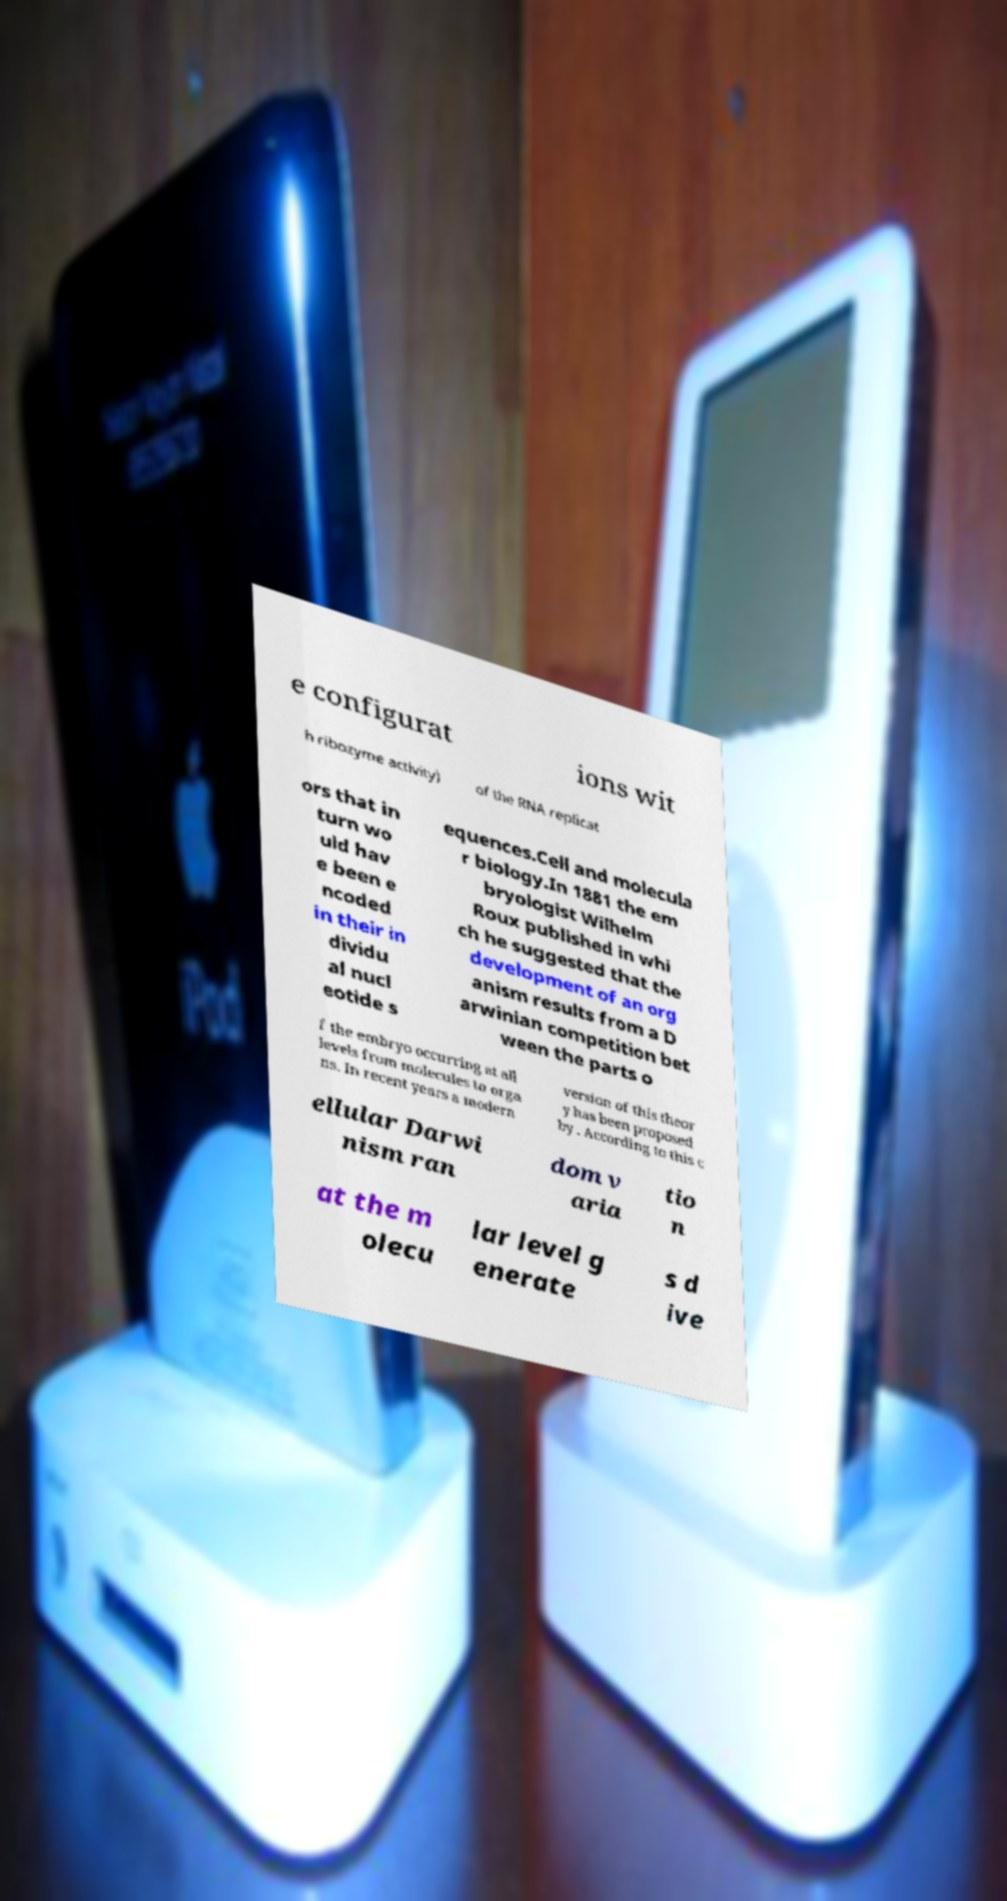There's text embedded in this image that I need extracted. Can you transcribe it verbatim? e configurat ions wit h ribozyme activity) of the RNA replicat ors that in turn wo uld hav e been e ncoded in their in dividu al nucl eotide s equences.Cell and molecula r biology.In 1881 the em bryologist Wilhelm Roux published in whi ch he suggested that the development of an org anism results from a D arwinian competition bet ween the parts o f the embryo occurring at all levels from molecules to orga ns. In recent years a modern version of this theor y has been proposed by . According to this c ellular Darwi nism ran dom v aria tio n at the m olecu lar level g enerate s d ive 